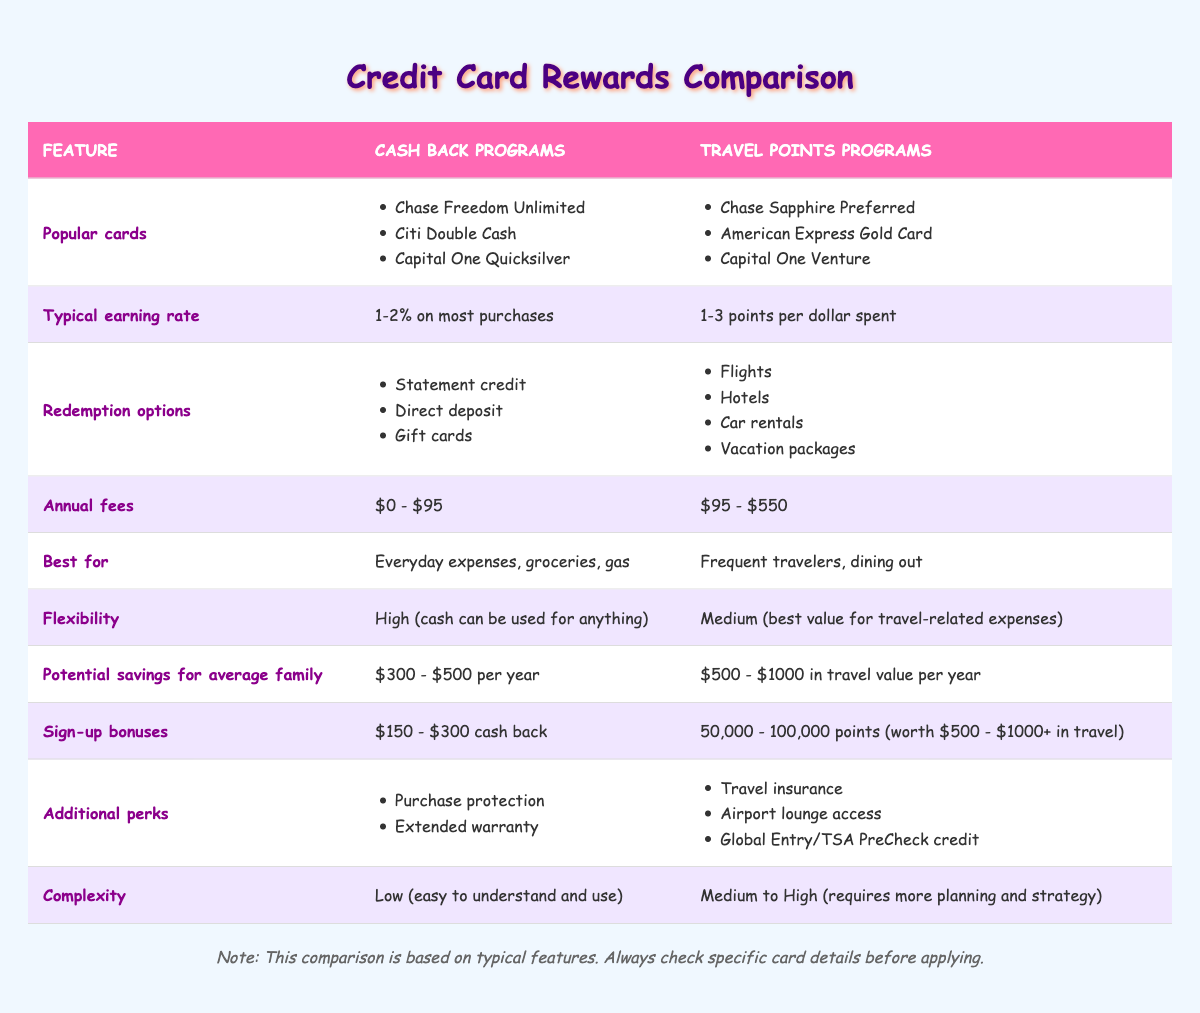What are some popular cash back card options? According to the table, the popular cash back card options are Chase Freedom Unlimited, Citi Double Cash, and Capital One Quicksilver.
Answer: Chase Freedom Unlimited, Citi Double Cash, Capital One Quicksilver What is the typical earning rate for travel points programs? The table shows that the typical earning rate for travel points programs is 1-3 points per dollar spent.
Answer: 1-3 points per dollar spent Do cash back programs typically have higher annual fees than travel points programs? By comparing the annual fees listed in the table, cash back programs have fees ranging from $0 to $95, while travel points programs range from $95 to $550. Therefore, the statement is false.
Answer: No Which program is best for everyday expenses? The table indicates that cash back programs are best for everyday expenses, groceries, and gas, while travel points programs are geared toward frequent travelers and dining out.
Answer: Cash Back Programs What is the difference in potential savings for an average family between cash back and travel points programs? According to the table, cash back programs offer potential savings of $300 to $500 per year, while travel points programs provide savings of $500 to $1000 in travel value per year. The difference can be calculated as $500 (higher end of cash back) vs. $1000 (higher end of travel points), leading to a difference of $500.
Answer: $500 Is the complexity level the same for cash back programs and travel points programs? The table indicates that cash back programs have low complexity, while travel points programs have medium to high complexity. Thus, they are not the same, and this statement is false.
Answer: No If a family prefers flexibility, which credit card program should they choose? Flexibility is high for cash back programs since cash can be used for anything. Travel points programs have medium flexibility, best for travel-related expenses. Therefore, a family that values flexibility should choose cash back programs.
Answer: Cash Back Programs What would be the average sign-up bonus for cash back programs compared to travel points? The cash back programs typically offer sign-up bonuses between $150 to $300, whereas travel points programs offer bonuses of 50,000 to 100,000 points, which can be valued at $500 to $1000+. To find an average for cash back, we take (150 + 300) / 2 = 225. The average value of travel points is (500 + 1000) / 2 = 750. Thus, cash back programs have an average sign-up bonus of $225, and travel points programs have $750.
Answer: Cash Back: $225, Travel Points: $750 Which type of card would provide additional perks like airport lounge access? Referring to the table, travel points programs include additional perks such as travel insurance, airport lounge access, and Global Entry/TSA PreCheck credit. Cash back programs do not include lounge access.
Answer: Travel Points Programs 